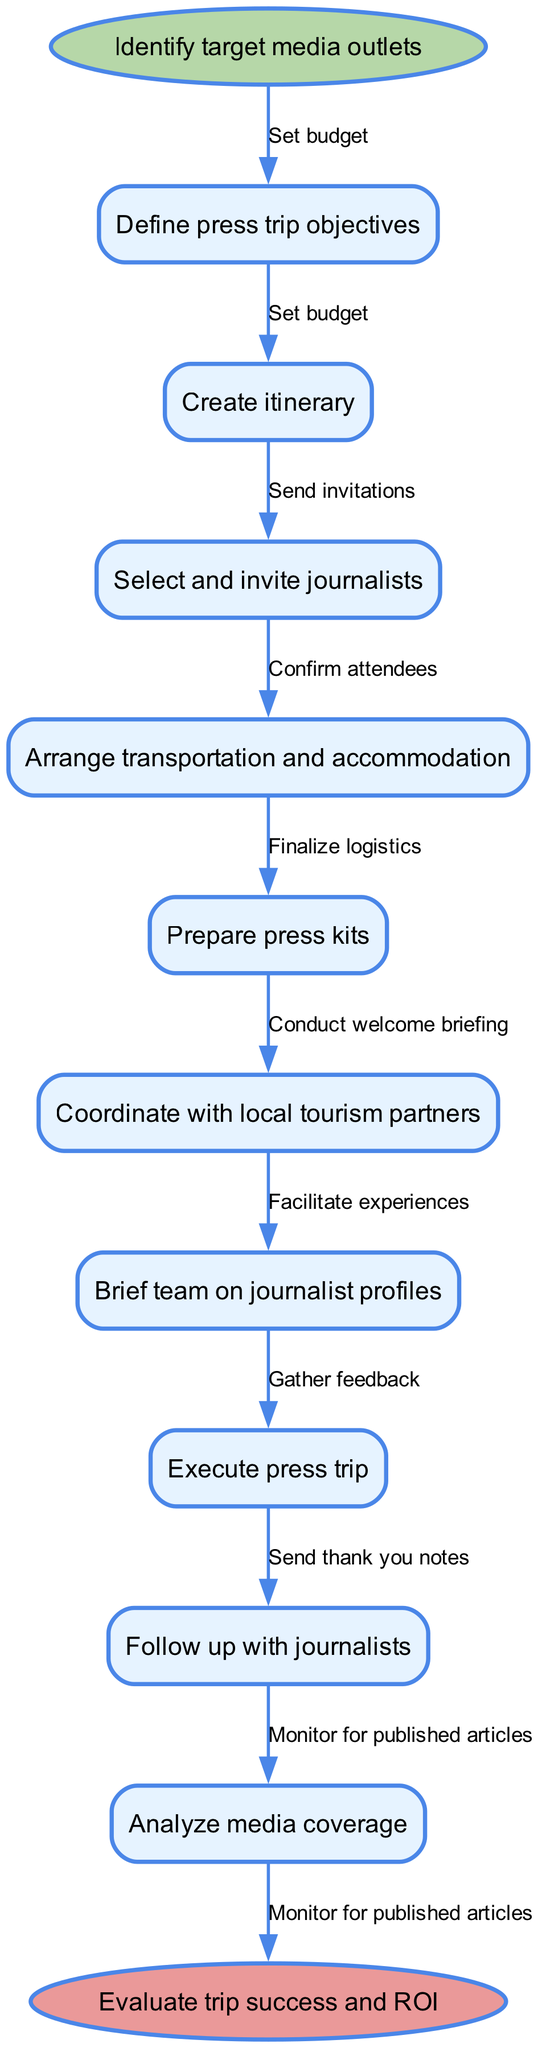What is the first step in coordinating a press trip? The diagram starts with the node labeled "Identify target media outlets," indicating that this is the first step in the process.
Answer: Identify target media outlets How many nodes are present in the diagram? Counting all the nodes listed under "nodes," there are a total of 10 nodes which include the start and end nodes.
Answer: 10 What is the last step after executing the press trip? The last node before the end node indicates "Follow up with journalists," meaning this is the final step before evaluating the success of the trip.
Answer: Follow up with journalists Which step involves creating communication materials for journalists? The diagram shows "Prepare press kits" as one of the nodes, which occurs after selecting and inviting journalists. This step specifically relates to creating materials for the journalists.
Answer: Prepare press kits What is the relationship between "Create itinerary" and "Arrange transportation and accommodation"? The edge connecting the two nodes shows that after "Create itinerary," the next logical step in the flow is to "Arrange transportation and accommodation," indicating a sequential relationship.
Answer: Finalize logistics Which two nodes are connected by the edge labeled "Send invitations"? The edge labeled "Send invitations" connects the starting node "Identify target media outlets" to the node "Select and invite journalists," demonstrating the progression from identifying media to invitations.
Answer: Identify target media outlets and Select and invite journalists What does the last edge in the flow chart signify? The last edge connects the final node "Analyze media coverage" to the end node, labeled "Evaluate trip success and ROI," indicating that the analysis leads directly to evaluating the effectiveness and return on investment of the trip.
Answer: Evaluate trip success and ROI Which step directly follows "Coordination with local tourism partners"? The node that directly follows "Coordinate with local tourism partners" is "Brief team on journalist profiles," showing that after coordinating partners, the next action is briefing the team.
Answer: Brief team on journalist profiles What are the contents placed before the "Execute press trip" step? Before the execution of the press trip, the contents include "Finalize logistics" which involves arrangements, and "Conduct welcome briefing" which sets the stage for executing the trip.
Answer: Finalize logistics and Conduct welcome briefing 